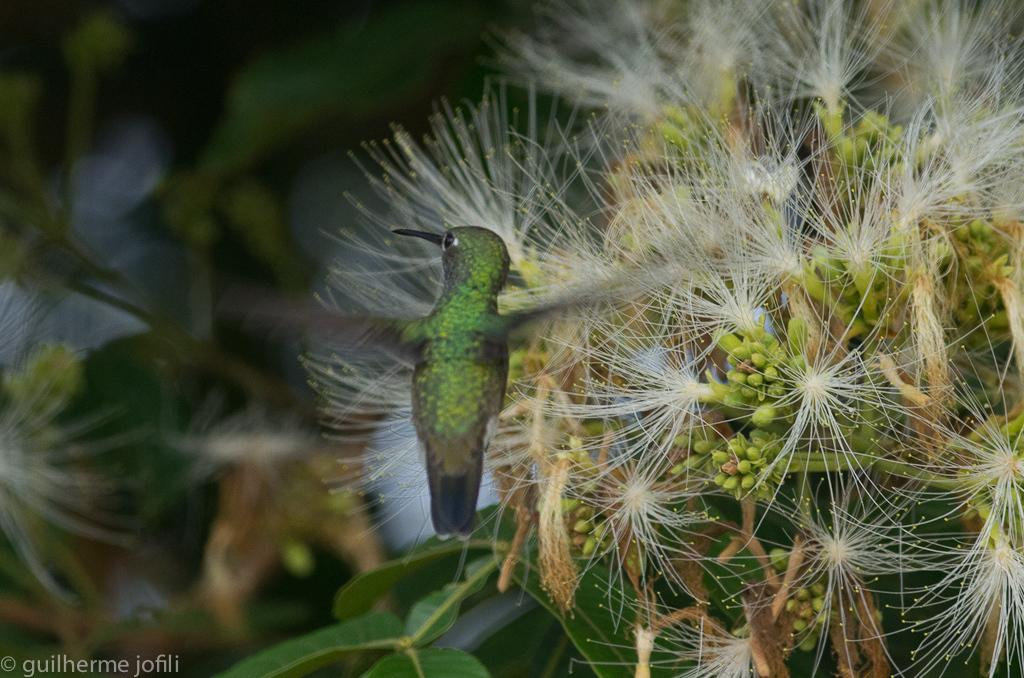What is the main subject in the foreground of the image? There is a bird in the foreground of the image. What can be seen behind the bird? There appear to be flowers behind the bird. How many times does the bird sneeze in the image? There is no indication of the bird sneezing in the image, as birds do not have the ability to sneeze. 